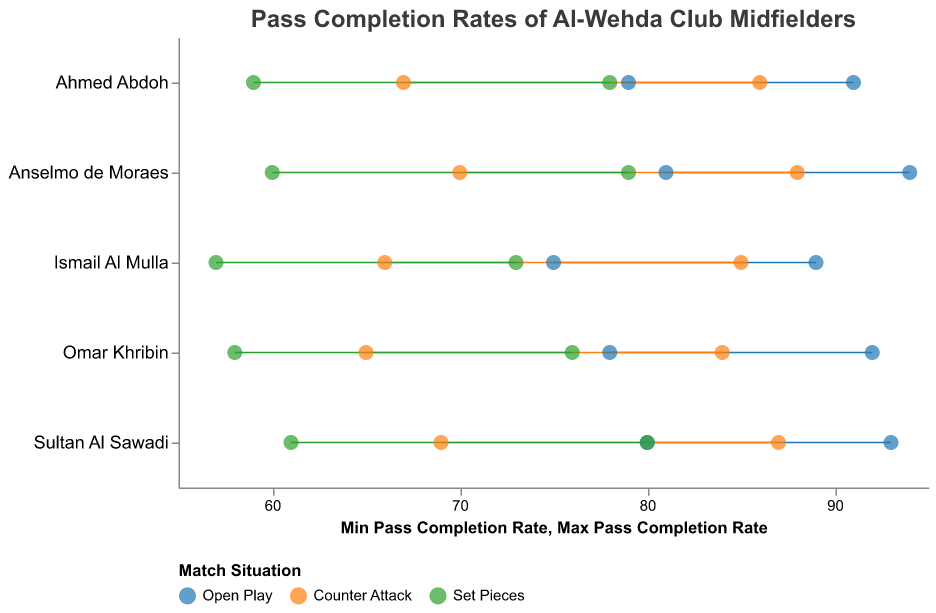What's the title of the Ranged Dot Plot? The title of the plot is usually placed at the top and is part of the visual information provided. In this case, the title is explicitly given in the plot's definition.
Answer: Pass Completion Rates of Al-Wehda Club Midfielders Which player has the highest maximum pass completion rate in open play? Look for the player with the highest value on the x-axis for the open play match situation, which is represented by a blue color. Anselmo de Moraes has a maximum pass completion rate of 94%.
Answer: Anselmo de Moraes What is the pass completion rate range for Ismail Al Mulla during counter attacks? Find the data points corresponding to Ismail Al Mulla in the counter attack category (in orange color). The range is given by the minimum and maximum values on the x-axis.
Answer: 66 to 85 Who has the lowest minimum pass completion rate in set pieces? Identify the data points for set pieces (in green color) and find the one with the lowest minimum value on the x-axis. Omar Khribin has the lowest minimum pass completion rate of 58%.
Answer: Omar Khribin Compare the minimum pass completion rates between open play and counter attacks for Ahmed Abdoh. Which one is higher? Look at Ahmed Abdoh's data points for open play and counter attacks. Compare the minimum values for each match situation. The minimum pass completion rate for open play is 79%, whereas for counter attacks it is 67%. Open play is higher.
Answer: Open play How does Sultan Al Sawadi's performance in set pieces compare to counter attacks in terms of maximum pass completion rate? Examine Sultan Al Sawadi's data points for set pieces and counter attacks. Compare the maximum values on the x-axis. The maximum pass completion rate for set pieces is 80%, and for counter attacks, it is 87%. Counter attacks have a higher maximum pass completion rate.
Answer: Counter attacks What is the average of the maximum pass completion rates for all players in open play? Find the maximum pass completion rates for all players in open play and calculate their average. The values are 92, 94, 89, 91, and 93. The sum is 459, and there are 5 players, so the average is 459/5 = 91.8%.
Answer: 91.8% Which player has the smallest range of pass completion rates in counter attacks? Calculate the range for each player by subtracting the minimum value from the maximum value for counter attacks. Compare the ranges for each player: Omar Khribin (19), Anselmo de Moraes (18), Ismail Al Mulla (19), Ahmed Abdoh (19), and Sultan Al Sawadi (18). Anselmo de Moraes and Sultan Al Sawadi both have the smallest range of 18%.
Answer: Anselmo de Moraes and Sultan Al Sawadi 